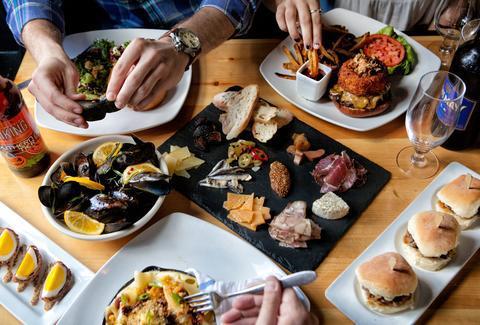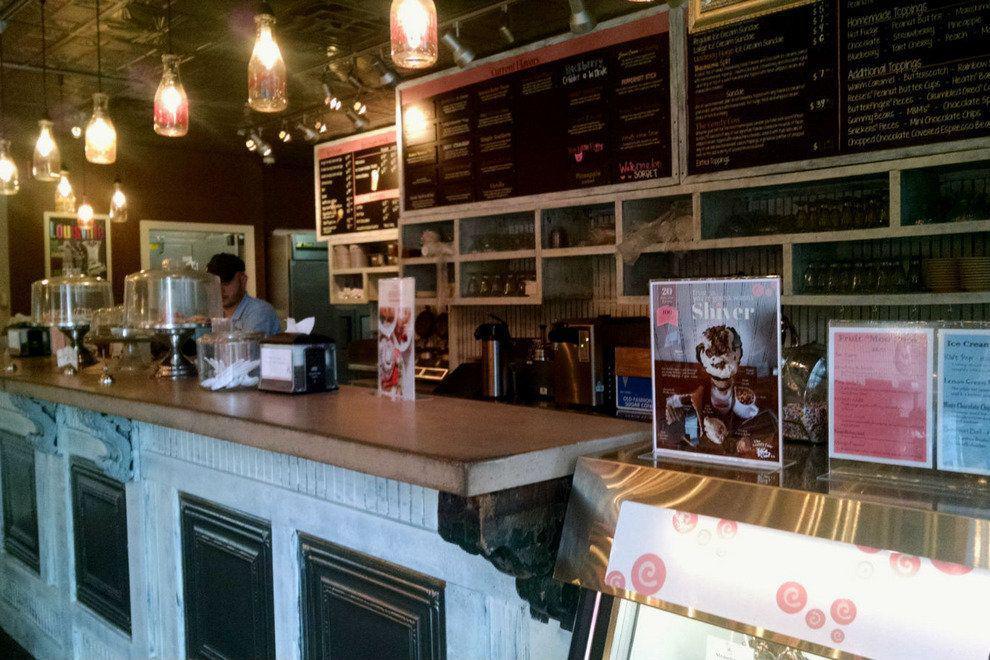The first image is the image on the left, the second image is the image on the right. Considering the images on both sides, is "There ae six dropped lights hanging over the long bar." valid? Answer yes or no. Yes. The first image is the image on the left, the second image is the image on the right. Assess this claim about the two images: "The vacant dining tables have lit candles on them.". Correct or not? Answer yes or no. No. 